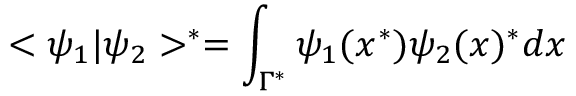<formula> <loc_0><loc_0><loc_500><loc_500>< \psi _ { 1 } | \psi _ { 2 } > ^ { * } = \int _ { \Gamma ^ { * } } \psi _ { 1 } ( x ^ { * } ) \psi _ { 2 } ( x ) ^ { * } d x</formula> 